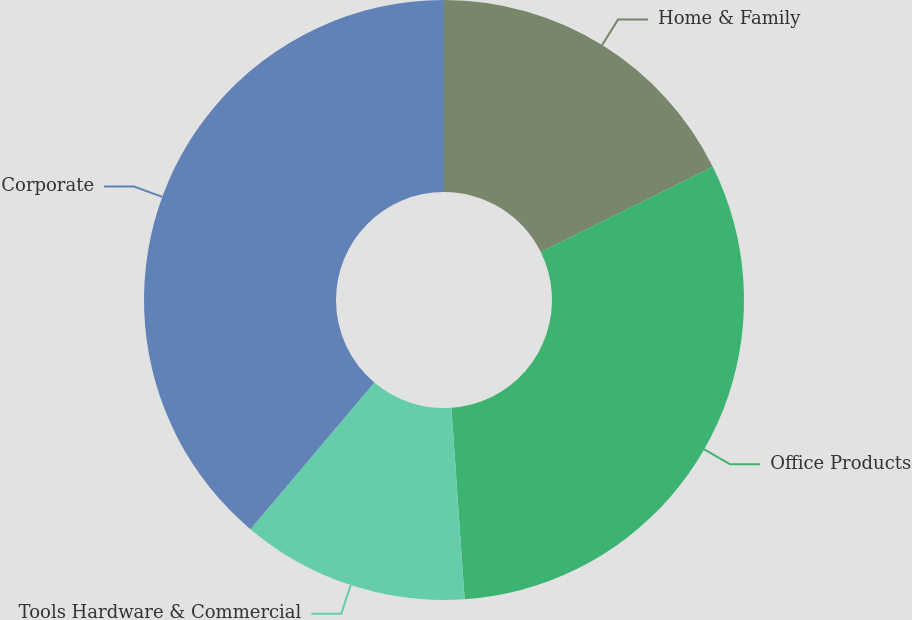Convert chart to OTSL. <chart><loc_0><loc_0><loc_500><loc_500><pie_chart><fcel>Home & Family<fcel>Office Products<fcel>Tools Hardware & Commercial<fcel>Corporate<nl><fcel>17.68%<fcel>31.23%<fcel>12.26%<fcel>38.84%<nl></chart> 